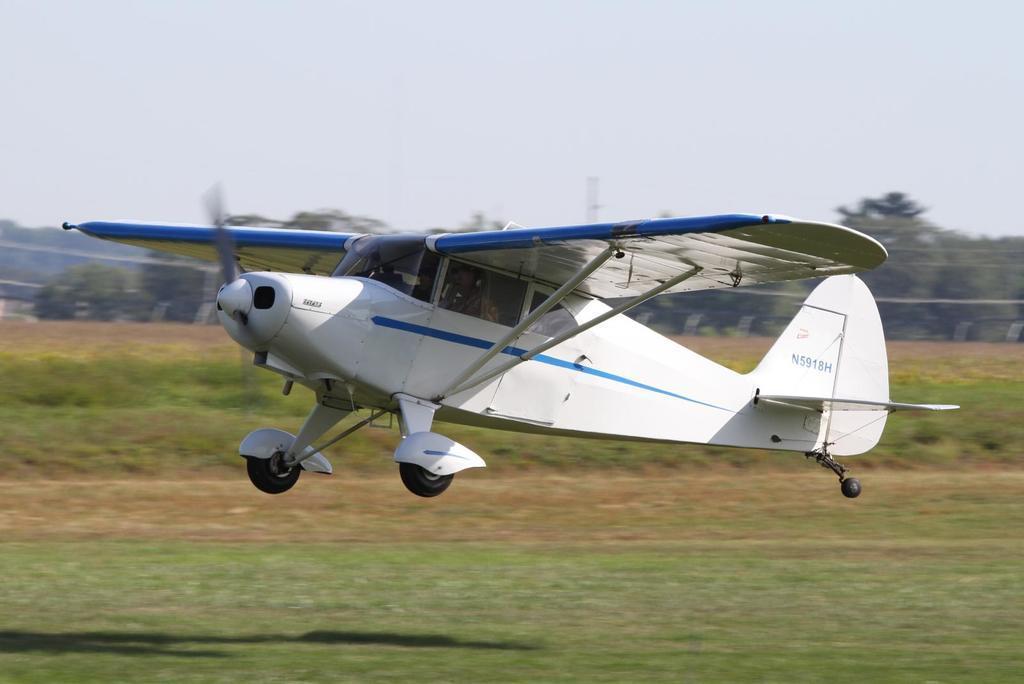Could you give a brief overview of what you see in this image? In this image there is a jet plane flying in the air, under that there are some grass fields, beside that there are some trees. 